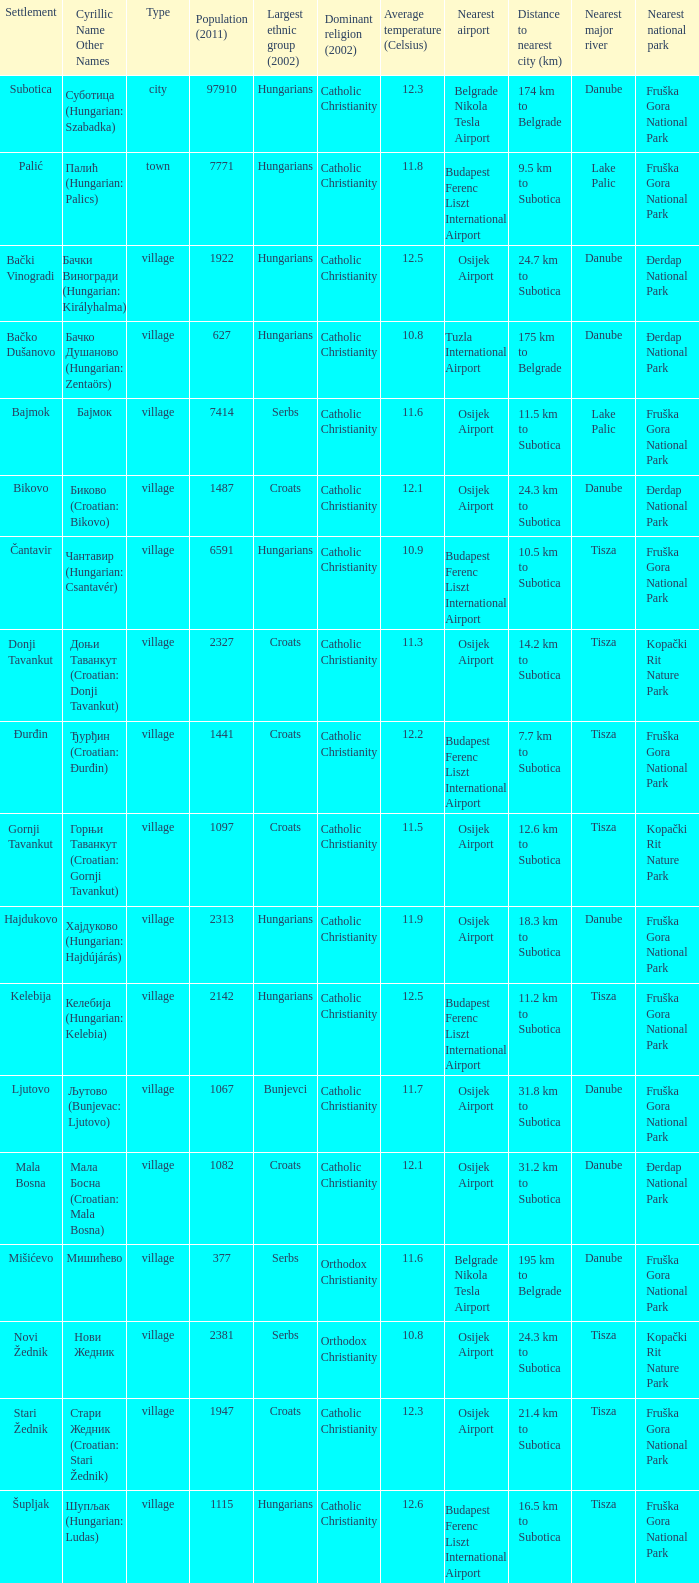How many settlements are named ђурђин (croatian: đurđin)? 1.0. 